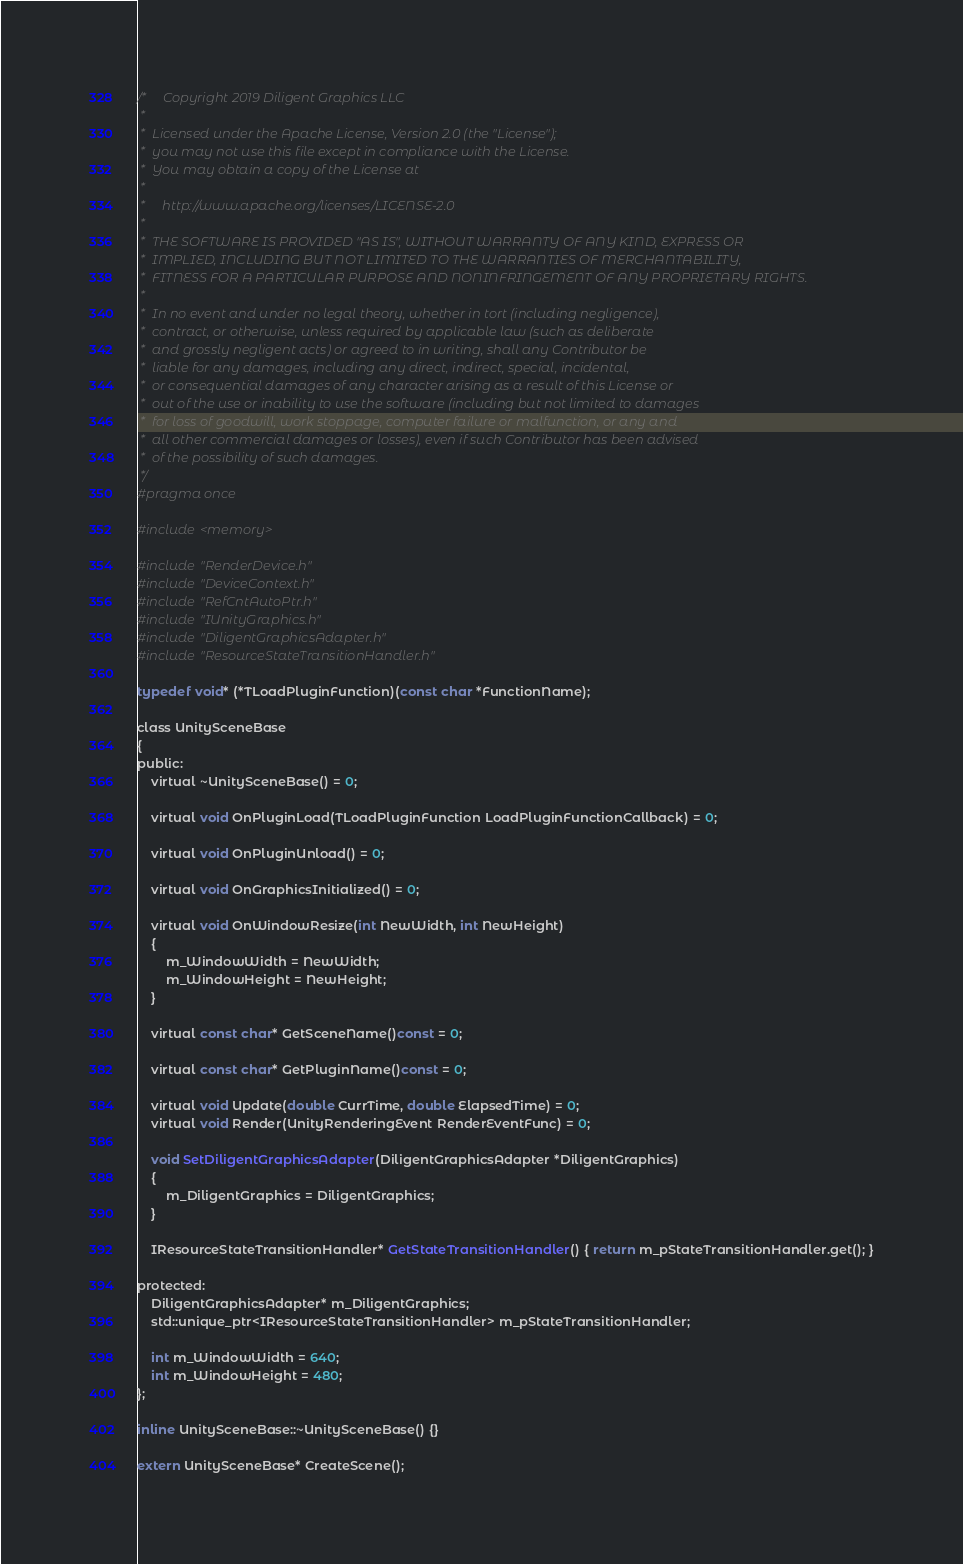<code> <loc_0><loc_0><loc_500><loc_500><_C_>/*     Copyright 2019 Diligent Graphics LLC
 *  
 *  Licensed under the Apache License, Version 2.0 (the "License");
 *  you may not use this file except in compliance with the License.
 *  You may obtain a copy of the License at
 * 
 *     http://www.apache.org/licenses/LICENSE-2.0
 * 
 *  THE SOFTWARE IS PROVIDED "AS IS", WITHOUT WARRANTY OF ANY KIND, EXPRESS OR
 *  IMPLIED, INCLUDING BUT NOT LIMITED TO THE WARRANTIES OF MERCHANTABILITY,
 *  FITNESS FOR A PARTICULAR PURPOSE AND NONINFRINGEMENT OF ANY PROPRIETARY RIGHTS.
 *
 *  In no event and under no legal theory, whether in tort (including negligence), 
 *  contract, or otherwise, unless required by applicable law (such as deliberate 
 *  and grossly negligent acts) or agreed to in writing, shall any Contributor be
 *  liable for any damages, including any direct, indirect, special, incidental, 
 *  or consequential damages of any character arising as a result of this License or 
 *  out of the use or inability to use the software (including but not limited to damages 
 *  for loss of goodwill, work stoppage, computer failure or malfunction, or any and 
 *  all other commercial damages or losses), even if such Contributor has been advised 
 *  of the possibility of such damages.
 */
#pragma once

#include <memory>

#include "RenderDevice.h"
#include "DeviceContext.h"
#include "RefCntAutoPtr.h"
#include "IUnityGraphics.h"
#include "DiligentGraphicsAdapter.h"
#include "ResourceStateTransitionHandler.h"

typedef void* (*TLoadPluginFunction)(const char *FunctionName);

class UnitySceneBase
{
public:
    virtual ~UnitySceneBase() = 0;

    virtual void OnPluginLoad(TLoadPluginFunction LoadPluginFunctionCallback) = 0;

    virtual void OnPluginUnload() = 0;

    virtual void OnGraphicsInitialized() = 0;

    virtual void OnWindowResize(int NewWidth, int NewHeight)
    {
        m_WindowWidth = NewWidth;
        m_WindowHeight = NewHeight;
    }

    virtual const char* GetSceneName()const = 0;

    virtual const char* GetPluginName()const = 0;

    virtual void Update(double CurrTime, double ElapsedTime) = 0;
    virtual void Render(UnityRenderingEvent RenderEventFunc) = 0;

    void SetDiligentGraphicsAdapter(DiligentGraphicsAdapter *DiligentGraphics)
    {
        m_DiligentGraphics = DiligentGraphics;
    }

    IResourceStateTransitionHandler* GetStateTransitionHandler() { return m_pStateTransitionHandler.get(); }

protected:
    DiligentGraphicsAdapter* m_DiligentGraphics;
    std::unique_ptr<IResourceStateTransitionHandler> m_pStateTransitionHandler;

    int m_WindowWidth = 640;
    int m_WindowHeight = 480;
};

inline UnitySceneBase::~UnitySceneBase() {}

extern UnitySceneBase* CreateScene();
</code> 